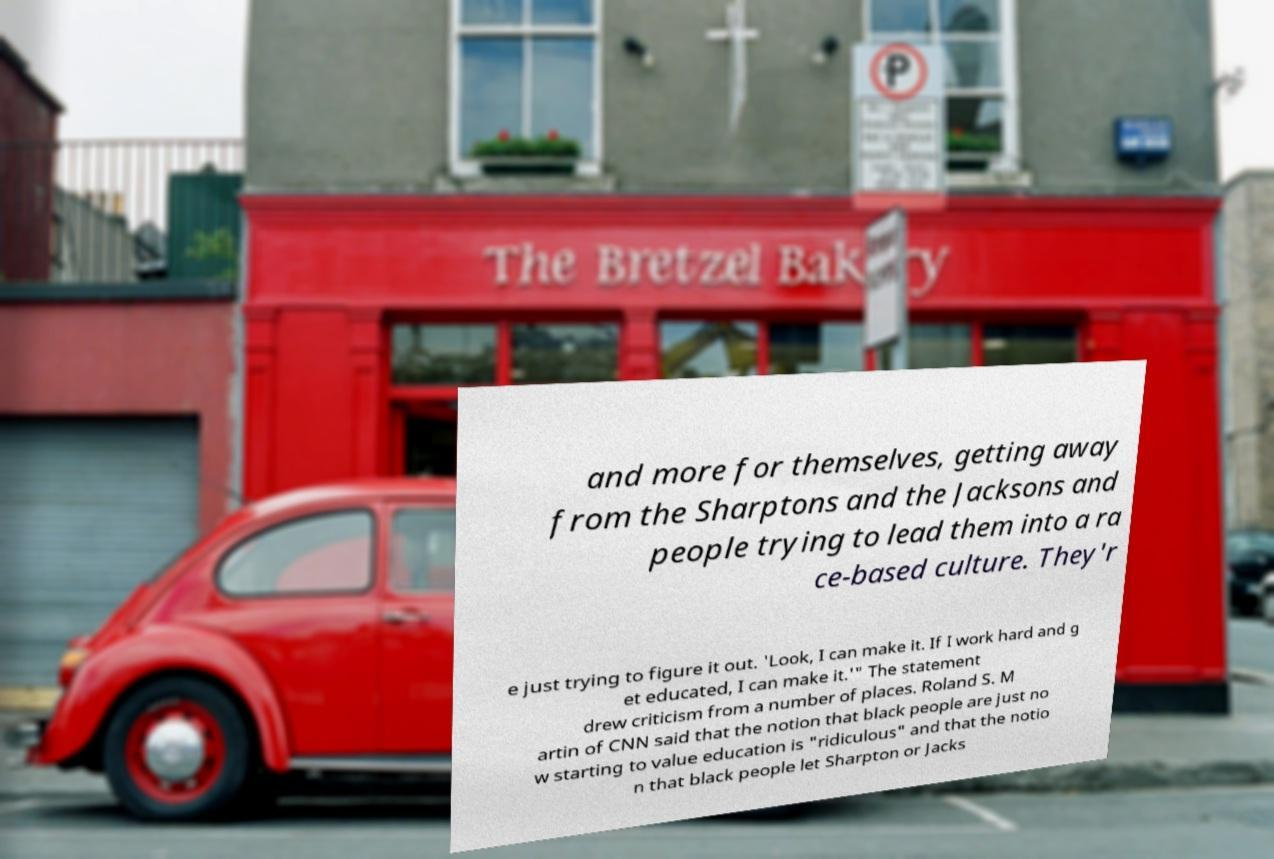Can you accurately transcribe the text from the provided image for me? and more for themselves, getting away from the Sharptons and the Jacksons and people trying to lead them into a ra ce-based culture. They'r e just trying to figure it out. 'Look, I can make it. If I work hard and g et educated, I can make it.'" The statement drew criticism from a number of places. Roland S. M artin of CNN said that the notion that black people are just no w starting to value education is "ridiculous" and that the notio n that black people let Sharpton or Jacks 